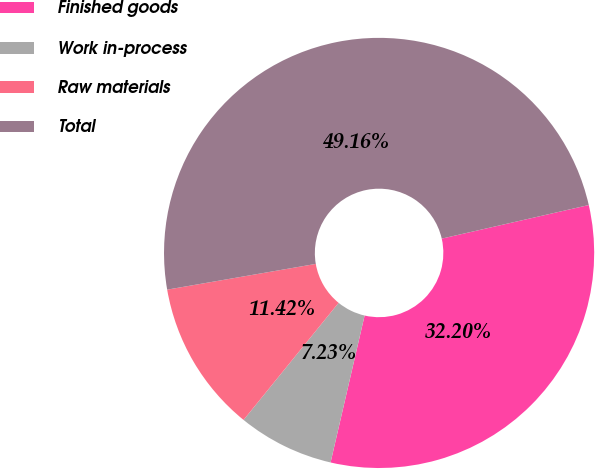<chart> <loc_0><loc_0><loc_500><loc_500><pie_chart><fcel>Finished goods<fcel>Work in-process<fcel>Raw materials<fcel>Total<nl><fcel>32.2%<fcel>7.23%<fcel>11.42%<fcel>49.16%<nl></chart> 